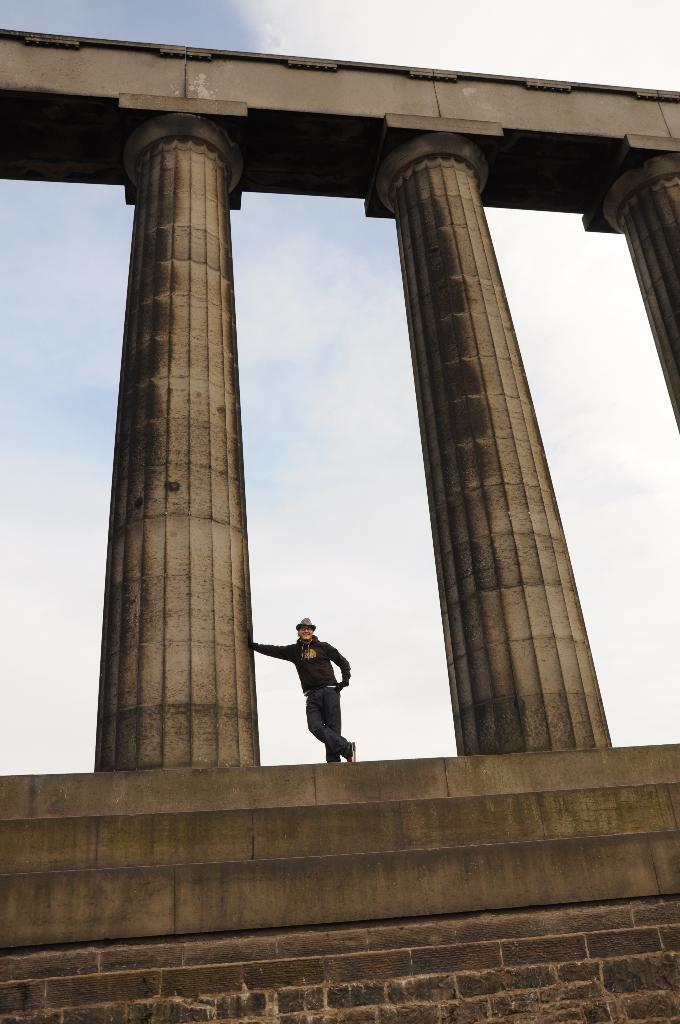What is the main subject of the image? There is a person standing in the image. What is the person standing on? The person is standing on a surface. What architectural features can be seen in the image? There are pillars visible in the image. What is visible in the sky in the image? Clouds are present in the sky. Can you tell me how many friends the person in the image has? There is no information about the person's friends in the image, so it cannot be determined. What type of maid is visible in the image? There is no maid present in the image. 